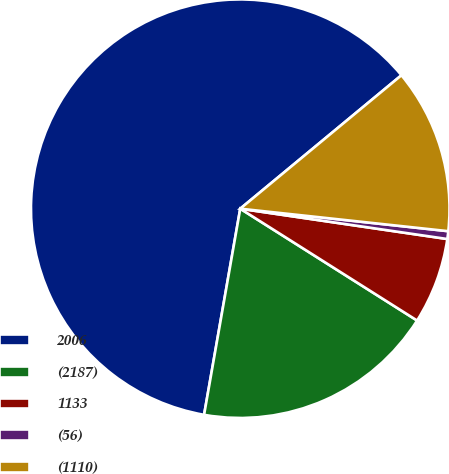Convert chart. <chart><loc_0><loc_0><loc_500><loc_500><pie_chart><fcel>2006<fcel>(2187)<fcel>1133<fcel>(56)<fcel>(1110)<nl><fcel>61.23%<fcel>18.79%<fcel>6.66%<fcel>0.6%<fcel>12.72%<nl></chart> 